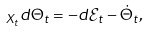Convert formula to latex. <formula><loc_0><loc_0><loc_500><loc_500>_ { X _ { t } } d \Theta _ { t } = - d \mathcal { E } _ { t } - \dot { \Theta } _ { t } ,</formula> 